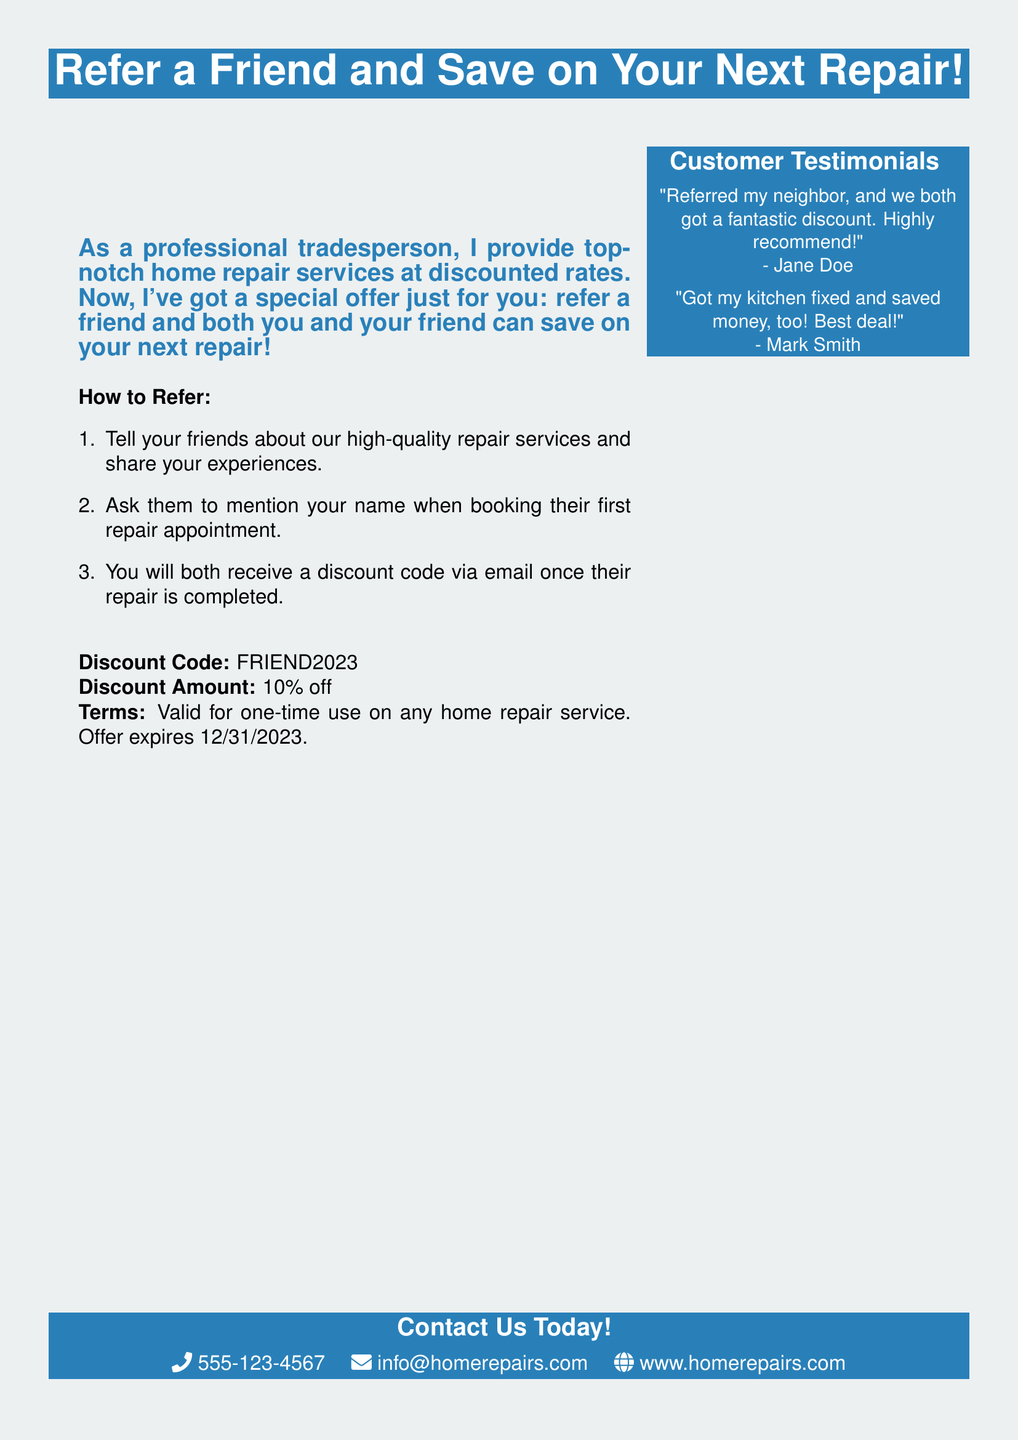What is the discount code for referrals? The discount code for referrals is provided in the advertisement for customers to use when they refer a friend.
Answer: FRIEND2023 How much discount do both you and your friend receive? The advertisement specifies the amount of discount that is applied to both the referrer and the friend.
Answer: 10% off When does the offer expire? The document includes the expiration date for the referral offer, which customers should be aware of.
Answer: 12/31/2023 What should friends mention when booking a repair? The advertisement instructs customers on what their referrals need to mention to qualify for the discount.
Answer: Your name Who is quoted in the testimonial, praising the referral program? The document features testimonials from satisfied customers, and one of them is named in a positive review about the service.
Answer: Jane Doe What is one of the three methods of contact provided? The advertisement includes contact methods, and this is one of the ways potential customers can get in touch.
Answer: Phone How many steps are in the referral process? The advertisement details the steps to complete the referral process, counting how many distinct actions need to be done.
Answer: 3 